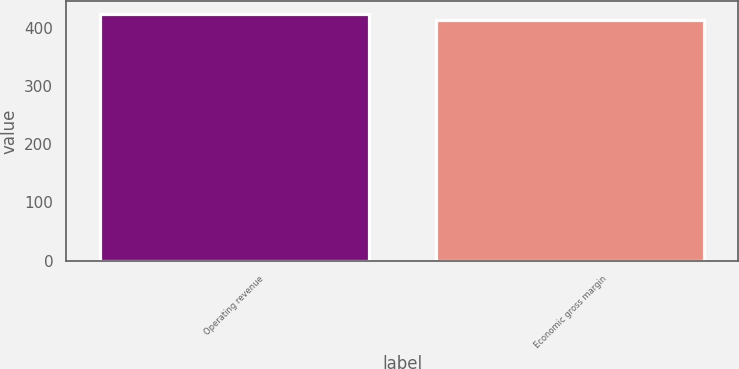Convert chart. <chart><loc_0><loc_0><loc_500><loc_500><bar_chart><fcel>Operating revenue<fcel>Economic gross margin<nl><fcel>424<fcel>413<nl></chart> 